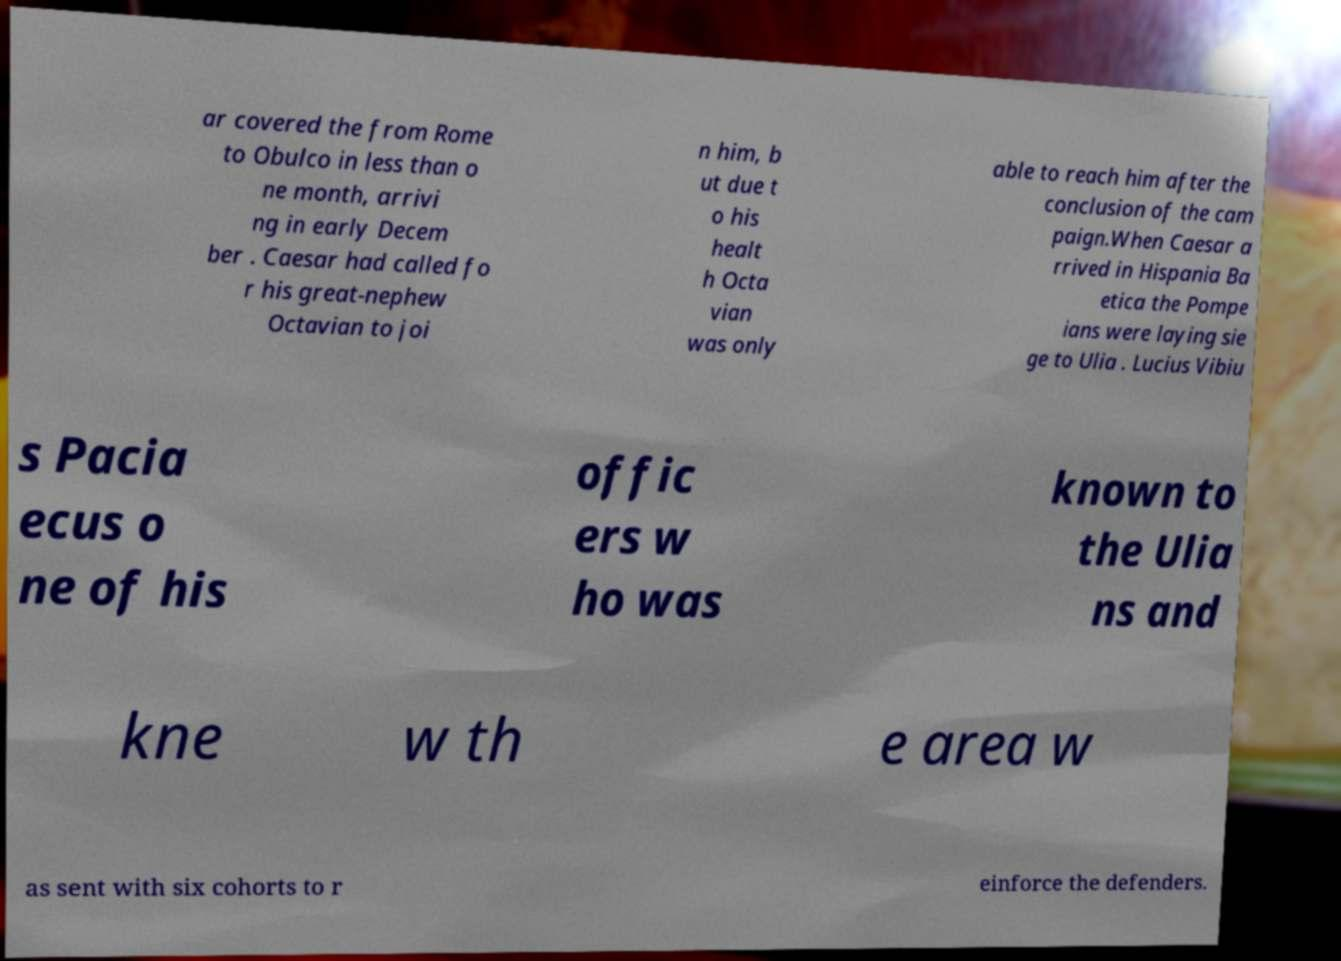What messages or text are displayed in this image? I need them in a readable, typed format. ar covered the from Rome to Obulco in less than o ne month, arrivi ng in early Decem ber . Caesar had called fo r his great-nephew Octavian to joi n him, b ut due t o his healt h Octa vian was only able to reach him after the conclusion of the cam paign.When Caesar a rrived in Hispania Ba etica the Pompe ians were laying sie ge to Ulia . Lucius Vibiu s Pacia ecus o ne of his offic ers w ho was known to the Ulia ns and kne w th e area w as sent with six cohorts to r einforce the defenders. 